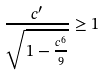<formula> <loc_0><loc_0><loc_500><loc_500>\frac { c ^ { \prime } } { \sqrt { 1 - \frac { c ^ { 6 } } { 9 } } } \geq 1</formula> 